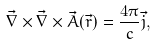<formula> <loc_0><loc_0><loc_500><loc_500>\vec { \nabla } \times \vec { \nabla } \times \vec { A } ( \vec { r } ) = \frac { 4 \pi } { c } \vec { j } ,</formula> 